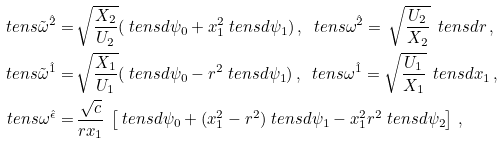Convert formula to latex. <formula><loc_0><loc_0><loc_500><loc_500>\ t e n s { \tilde { \omega } } ^ { \hat { 2 } } = & \, \sqrt { \frac { X _ { 2 } } { U _ { 2 } } } ( \ t e n s { d } \psi _ { 0 } + x _ { 1 } ^ { 2 } \ t e n s { d } \psi _ { 1 } ) \, , \ \ t e n s { \omega } ^ { \hat { 2 } } = \, \sqrt { \frac { U _ { 2 } } { X _ { 2 } } } \, \ t e n s { d } r \, , \\ \ t e n s { \tilde { \omega } } ^ { \hat { 1 } } = & \, \sqrt { \frac { X _ { 1 } } { U _ { 1 } } } ( \ t e n s { d } \psi _ { 0 } - r ^ { 2 } \ t e n s { d } \psi _ { 1 } ) \, , \ \ t e n s { \omega } ^ { \hat { 1 } } = \sqrt { \frac { U _ { 1 } } { X _ { 1 } } } \, \ t e n s { d } x _ { 1 } \, , \\ \ t e n s { \omega } ^ { \hat { \epsilon } } = & \, \frac { \sqrt { c } } { r x _ { 1 } } \, \left [ \ t e n s { d } \psi _ { 0 } + ( x _ { 1 } ^ { 2 } - r ^ { 2 } ) \ t e n s { d } \psi _ { 1 } - x _ { 1 } ^ { 2 } r ^ { 2 } \ t e n s { d } \psi _ { 2 } \right ] \, ,</formula> 